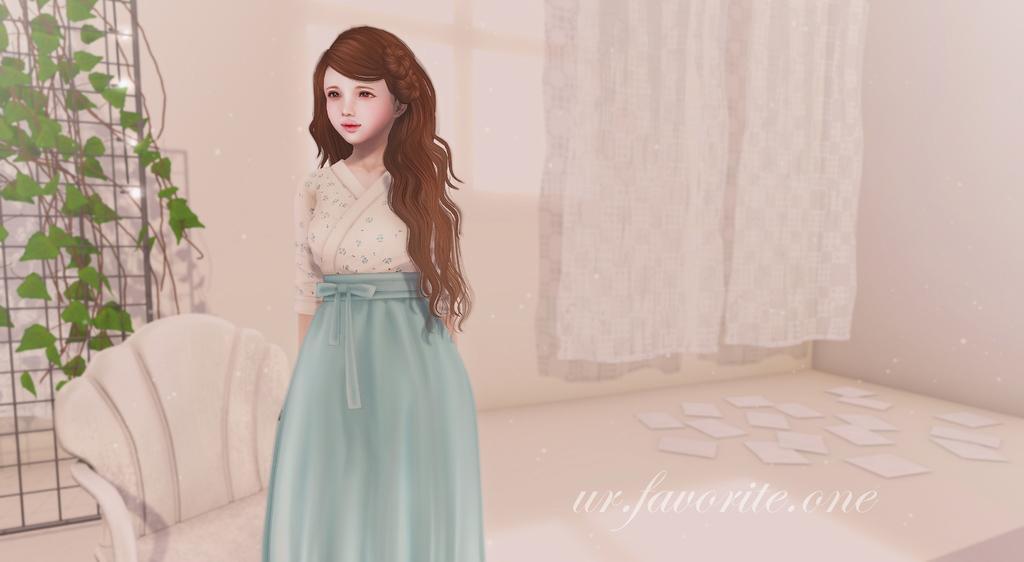Describe this image in one or two sentences. This is an animation image. In this image we can see a chair, girl standing on the floor, curtain, creeper to the grills and papers on the floor. 